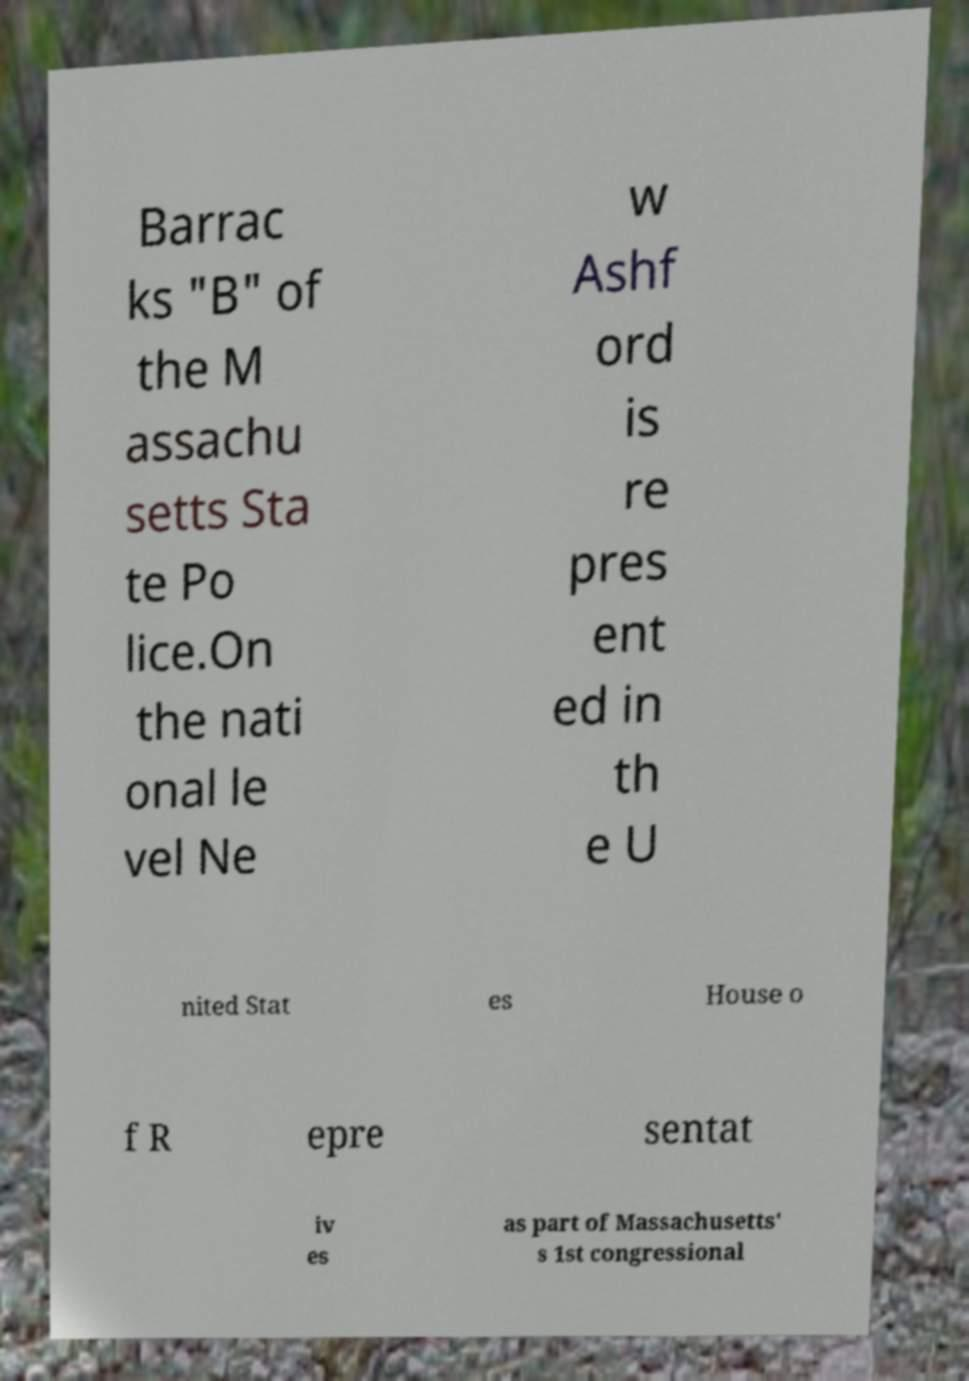Could you extract and type out the text from this image? Barrac ks "B" of the M assachu setts Sta te Po lice.On the nati onal le vel Ne w Ashf ord is re pres ent ed in th e U nited Stat es House o f R epre sentat iv es as part of Massachusetts' s 1st congressional 